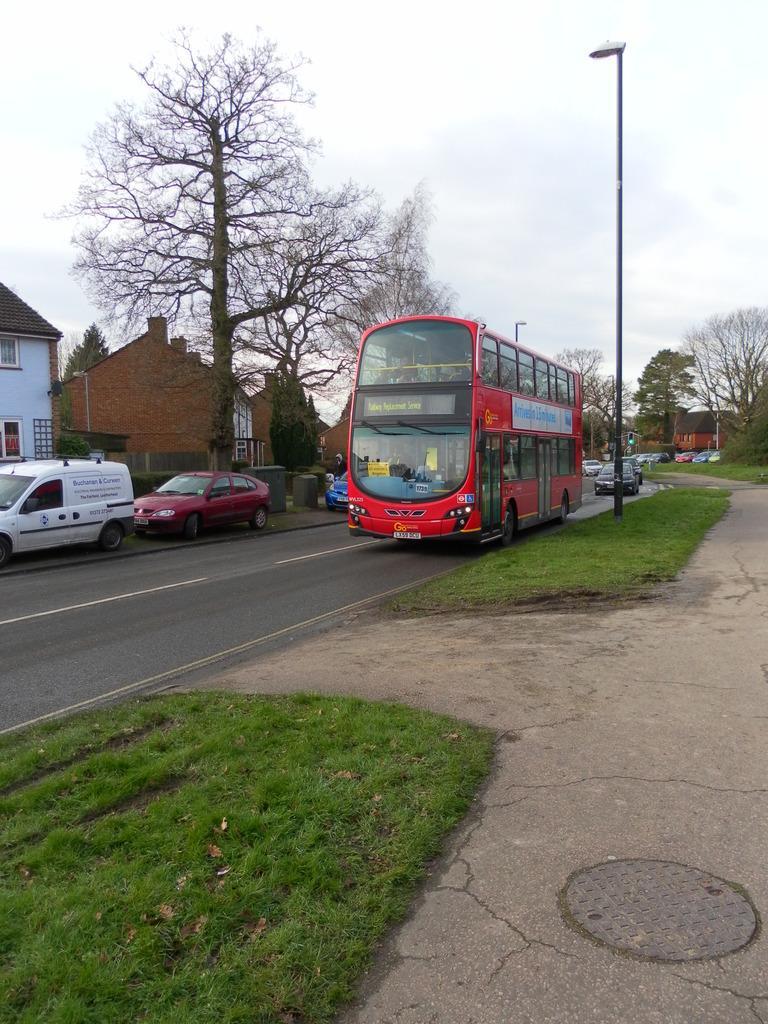Can you describe this image briefly? The picture is taken outside a city. In the foreground of the picture there are dry leaves, grass and footpath. In the center of the picture there are houses, trees, street lights, cars and a bus. Sky is cloudy. 